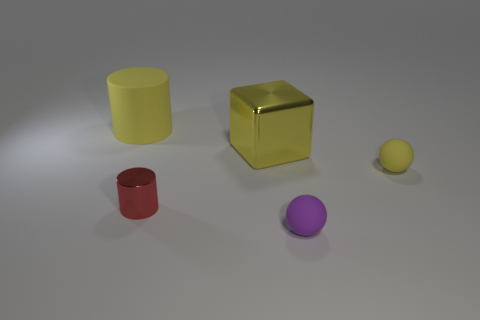What could be the purpose of arranging these objects in such a manner? This arrangement of objects seems to be a simplistic still life setup, likely created for the purpose of a visual exercise, artistic study, or to test the composition and lighting in a 3D rendering or photographic setting. What does this setup suggest about the objects' potential uses? Despite their simplicity, these objects could represent everyday items. The cylinder and block could be containers or building toys, the smaller sphere might be a ball, and the smaller cylinder could be a cup. Their arrangement does not offer much insight into use but might encourage contemplation of form, color, and size in mundane objects. 